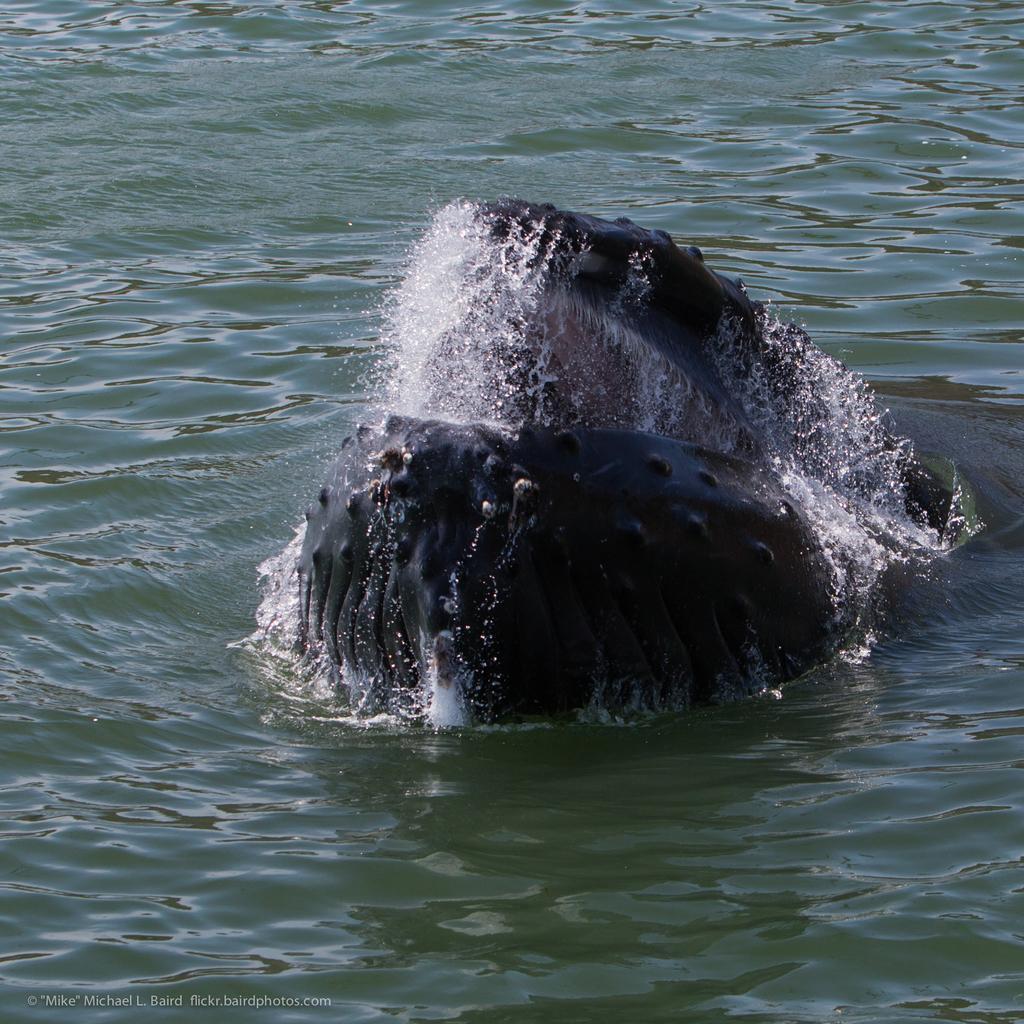How would you summarize this image in a sentence or two? In this picture we can see a whale here, at the bottom there is water. 